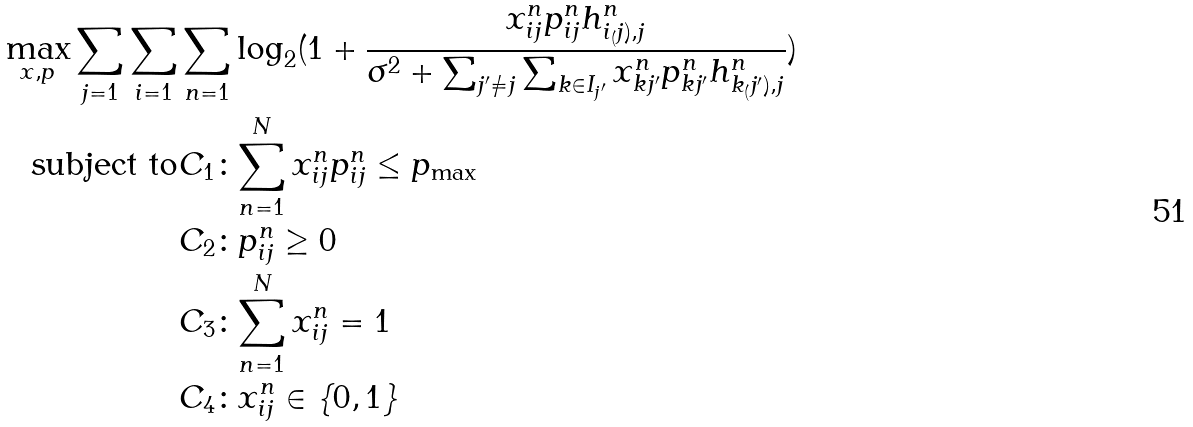Convert formula to latex. <formula><loc_0><loc_0><loc_500><loc_500>\max _ { x , p } \sum _ { j = 1 } \sum _ { i = 1 } & \sum _ { n = 1 } \log _ { 2 } ( 1 + \frac { x ^ { n } _ { i j } p ^ { n } _ { i j } h ^ { n } _ { i _ { ( } j ) , j } } { \sigma ^ { 2 } + \sum _ { j ^ { \prime } \neq j } \sum _ { k \in I _ { j ^ { \prime } } } x ^ { n } _ { k j ^ { \prime } } p ^ { n } _ { k j ^ { \prime } } h ^ { n } _ { k _ { ( } j ^ { \prime } ) , j } } ) \\ \text {subject to} & { { C } _ { 1 } } \colon \underset { n = 1 } { \overset { N } { \mathop \sum } } \, x _ { i j } ^ { n } p _ { i j } ^ { n } \leq { { p } _ { \max } } \\ & { { C } _ { 2 } } \colon p _ { i j } ^ { n } \geq 0 \\ & { { C } _ { 3 } } \colon \underset { n = 1 } { \overset { N } { \mathop \sum } } \, x _ { i j } ^ { n } = 1 \\ & { { C } _ { 4 } } \colon x _ { i j } ^ { n } \in \left \{ 0 , 1 \right \} \\</formula> 